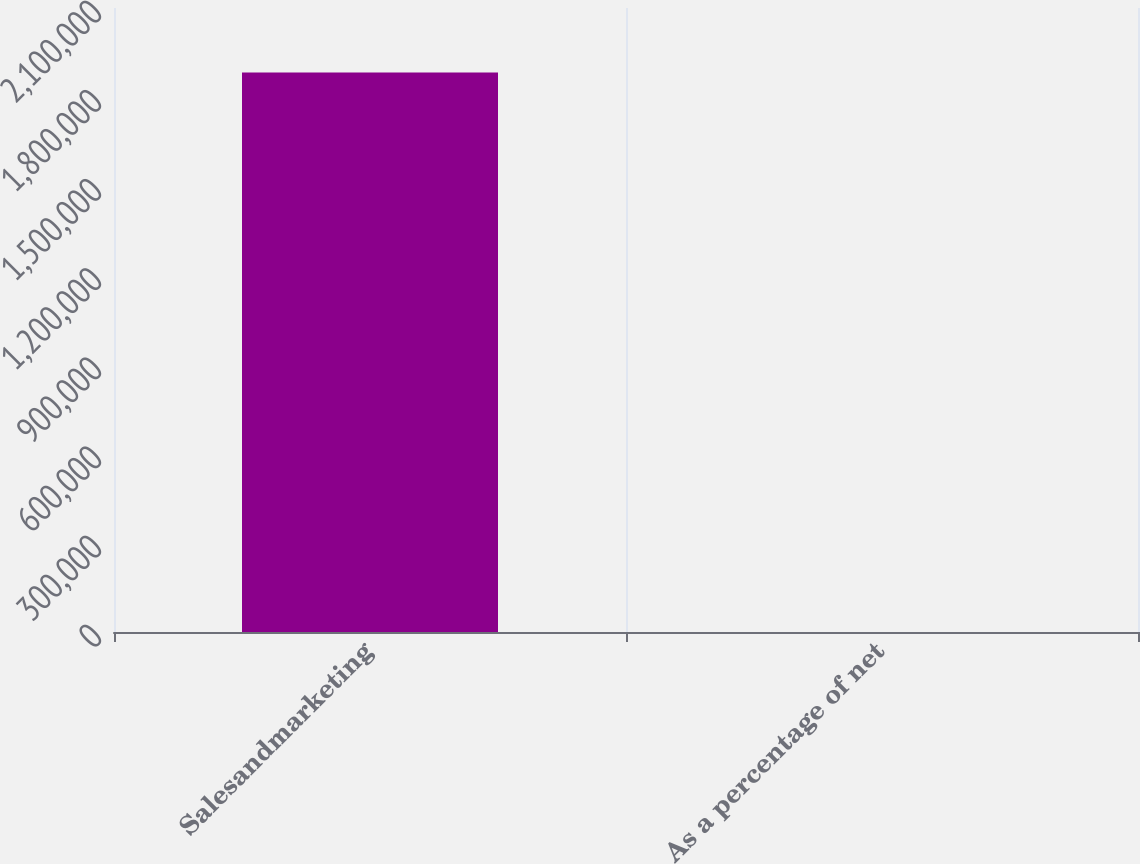Convert chart to OTSL. <chart><loc_0><loc_0><loc_500><loc_500><bar_chart><fcel>Salesandmarketing<fcel>As a percentage of net<nl><fcel>1.88281e+06<fcel>24.5<nl></chart> 